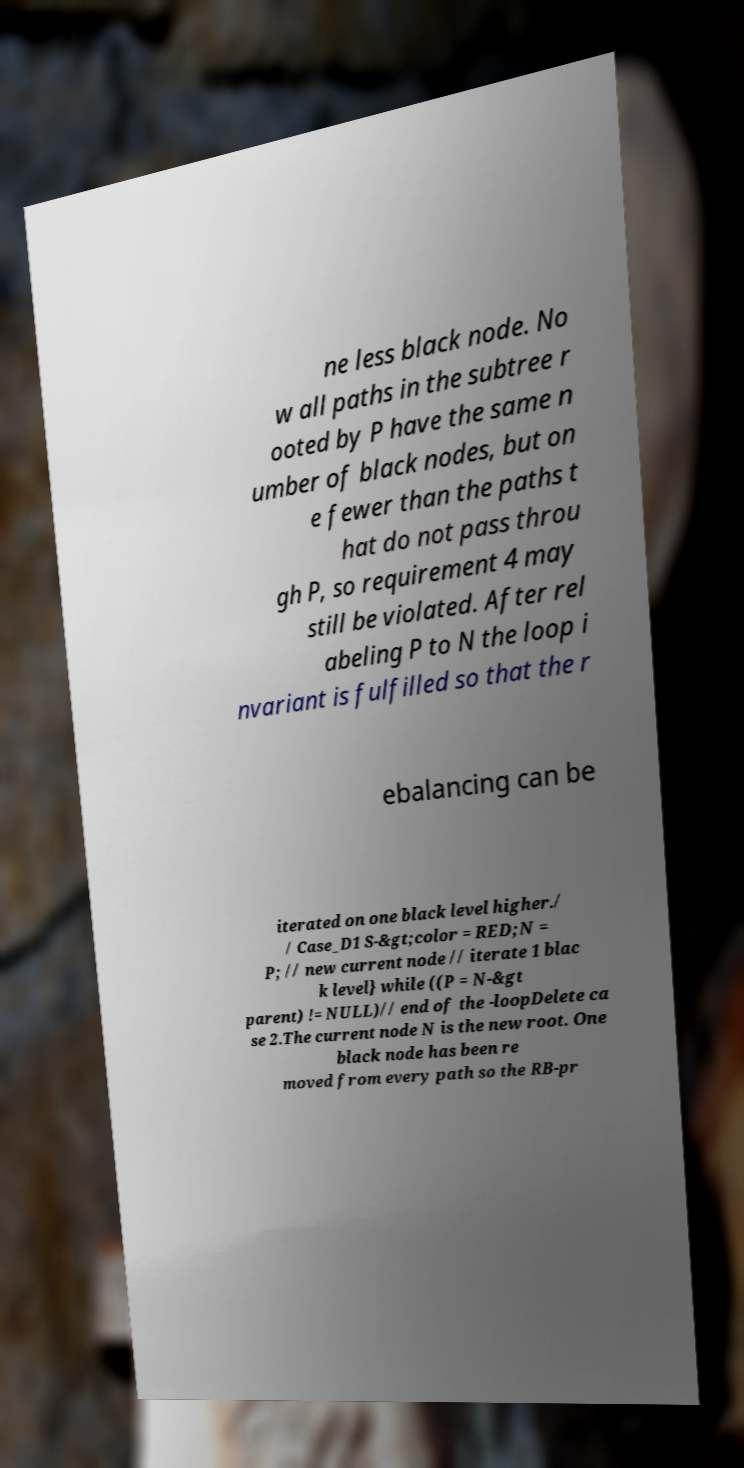Please read and relay the text visible in this image. What does it say? ne less black node. No w all paths in the subtree r ooted by P have the same n umber of black nodes, but on e fewer than the paths t hat do not pass throu gh P, so requirement 4 may still be violated. After rel abeling P to N the loop i nvariant is fulfilled so that the r ebalancing can be iterated on one black level higher./ / Case_D1 S-&gt;color = RED;N = P; // new current node // iterate 1 blac k level} while ((P = N-&gt parent) != NULL)// end of the -loopDelete ca se 2.The current node N is the new root. One black node has been re moved from every path so the RB-pr 